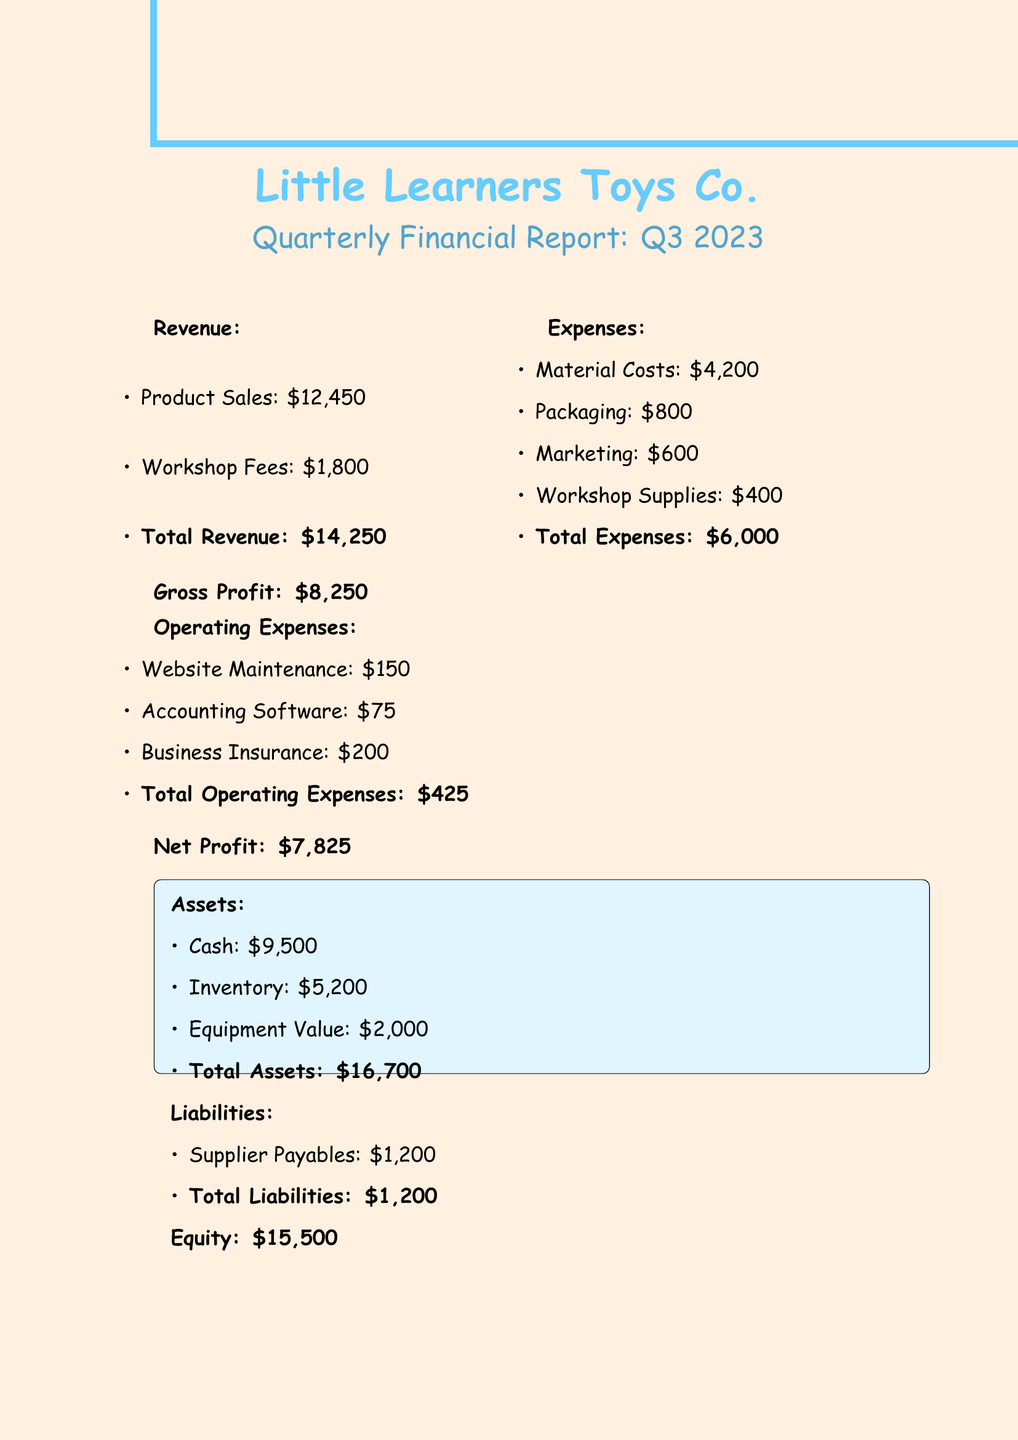what is the total revenue? The total revenue is the sum of product sales and workshop fees in the document, which is $12,450 + $1,800 = $14,250.
Answer: $14,250 what is the net profit? The net profit is the total revenue minus total expenses and operating expenses, resulting in $14,250 - $6,000 - $425 = $7,825.
Answer: $7,825 what are the top selling products? The document lists the three top selling products of the business: Alphabet Puzzle Blocks, Counting Caterpillar, and Storytelling Puppet Set.
Answer: Alphabet Puzzle Blocks, Counting Caterpillar, Storytelling Puppet Set what were the total expenses? Total expenses include material costs, packaging, marketing, and workshop supplies, summing up to $4,200 + $800 + $600 + $400 = $6,000.
Answer: $6,000 how many weekend workshops were conducted? The document states that 3 successful weekend workshops were conducted for local preschools, as noted under notable achievements.
Answer: 3 what is the value of cash assets? The cash assets are specified in the document as $9,500.
Answer: $9,500 what is the total equity? Total equity is listed in the document as $15,500.
Answer: $15,500 what is the total liabilities? The total liabilities are provided in the document as $1,200, which includes supplier payables.
Answer: $1,200 what is one of the upcoming goals? One of the upcoming goals mentioned in the document is to expand the product range with 2 new educational toys.
Answer: Expand product range with 2 new educational toys 